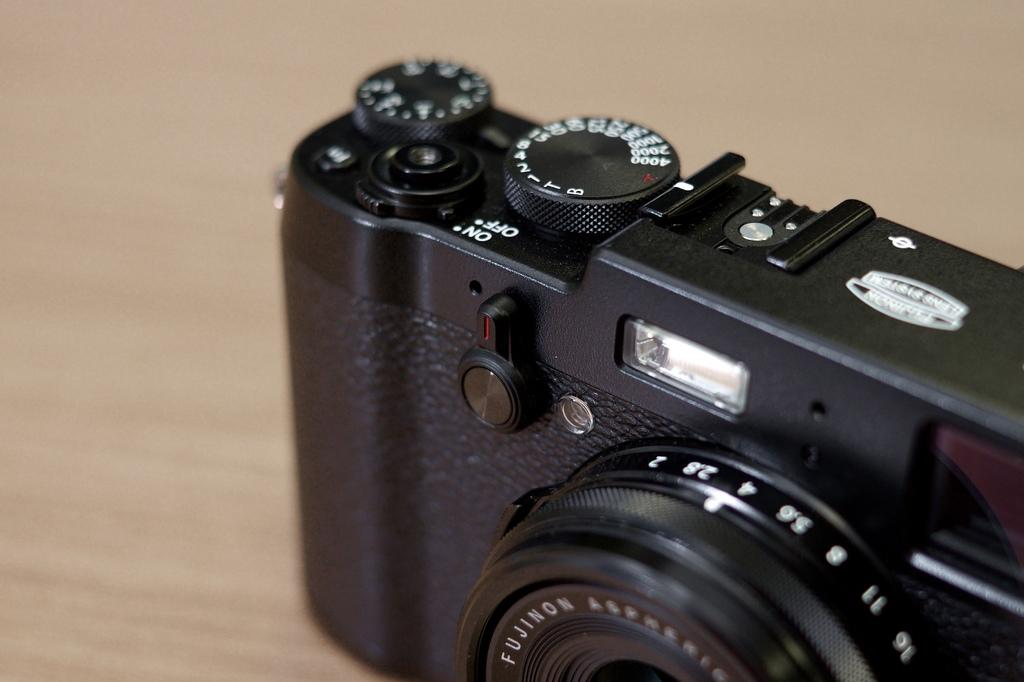<image>
Create a compact narrative representing the image presented. A closeup of a camera that has an analog on and off switch. 